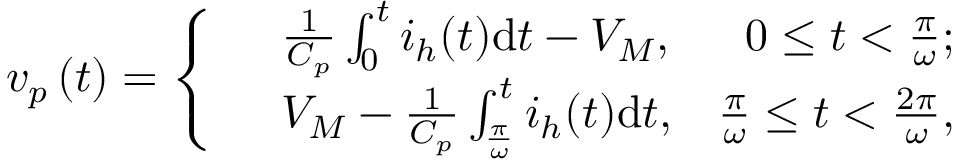Convert formula to latex. <formula><loc_0><loc_0><loc_500><loc_500>{ v _ { p } } \left ( t \right ) = \left \{ \begin{array} { r l r } & { \frac { 1 } { C _ { p } } \int _ { 0 } ^ { t } i _ { h } ( t ) d t - { V _ { M } } , } & { 0 \leq t < \frac { \pi } { \omega } ; } \\ & { { V _ { M } } - \frac { 1 } { C _ { p } } \int _ { \frac { \pi } { \omega } } ^ { t } i _ { h } ( t ) d t , } & { \frac { \pi } { \omega } \leq t < \frac { 2 \pi } { \omega } , } \end{array}</formula> 